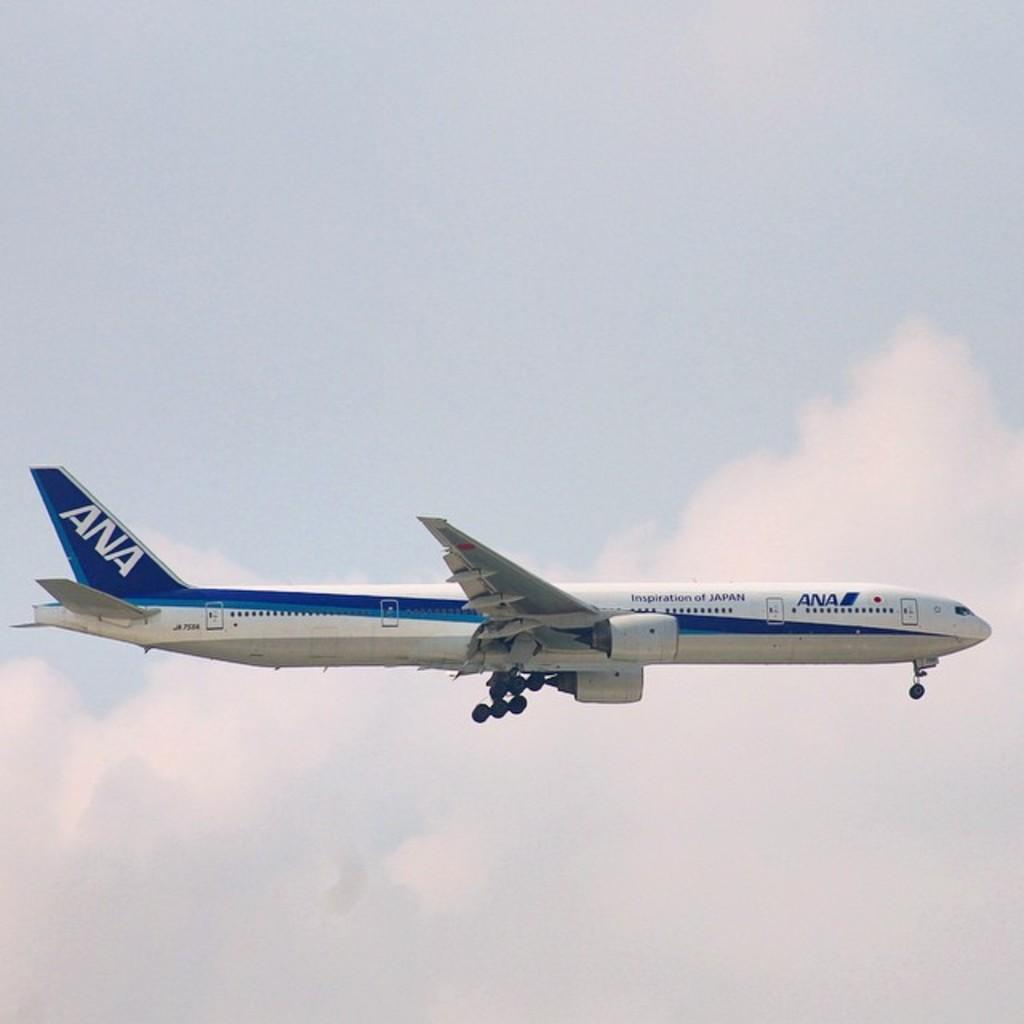<image>
Summarize the visual content of the image. A jet airplane operating under ANA with a message printed on the side stating Inspiration of Japan. 